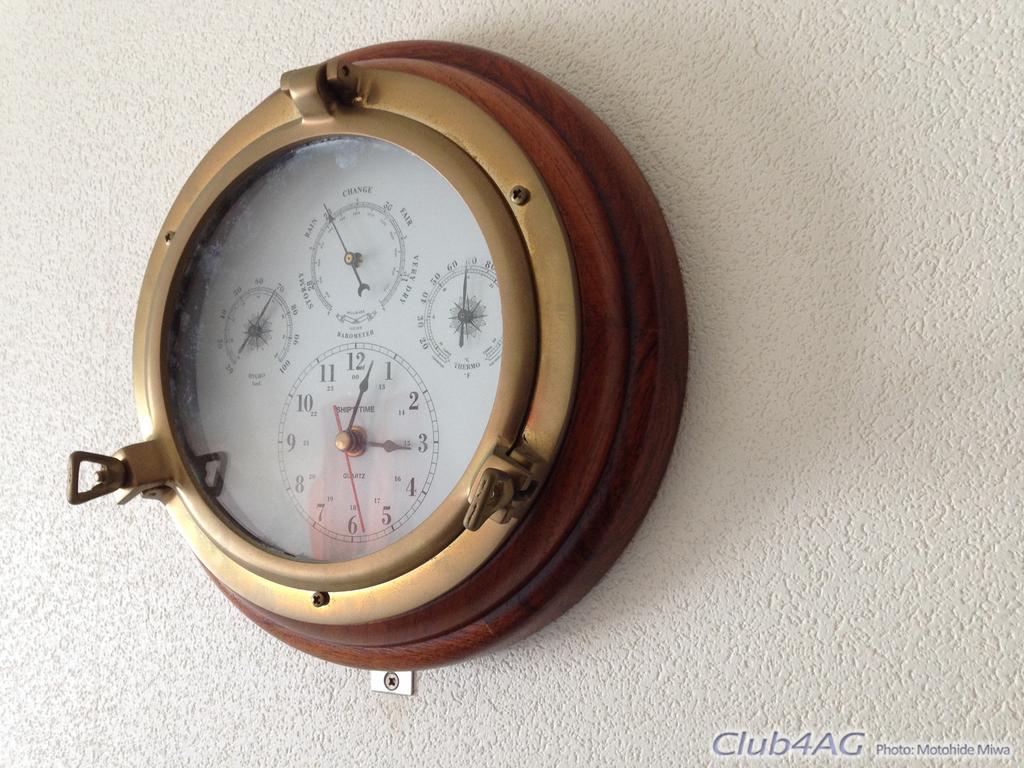What time is it?
Provide a short and direct response. 3:03. 